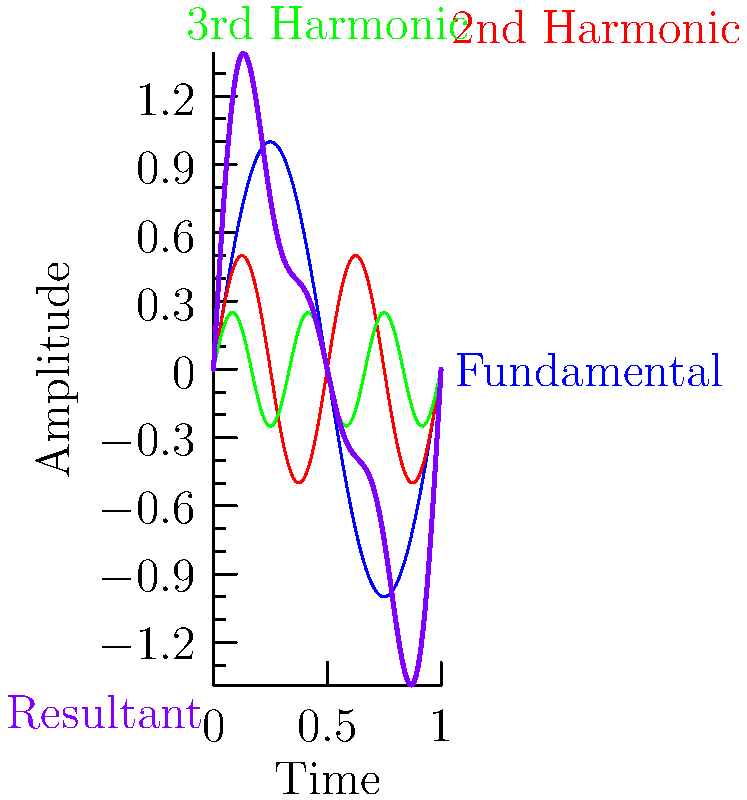In the graph above, which color represents the fundamental frequency of a blues guitar chord, and how does it relate to the other harmonic overtones? To understand the harmonic overtones in a blues guitar chord:

1. The fundamental frequency (blue line) represents the base note of the chord. It has the largest amplitude and lowest frequency.

2. The red line represents the 2nd harmonic, which has:
   - Twice the frequency of the fundamental
   - Half the amplitude of the fundamental

3. The green line represents the 3rd harmonic, which has:
   - Three times the frequency of the fundamental
   - One-quarter the amplitude of the fundamental

4. The purple line is the resultant waveform, combining all harmonics:
   - It represents the actual sound wave produced by the guitar
   - Its complex shape is due to the superposition of all harmonics

5. In blues guitar, these overtones contribute to the rich, warm tone characteristic of the genre.

6. The fundamental frequency (blue) is crucial as it defines the perceived pitch of the note, while the overtones add timbral qualities that make the guitar sound distinct from other instruments.
Answer: Blue; it has the largest amplitude and lowest frequency, forming the base for higher harmonics. 